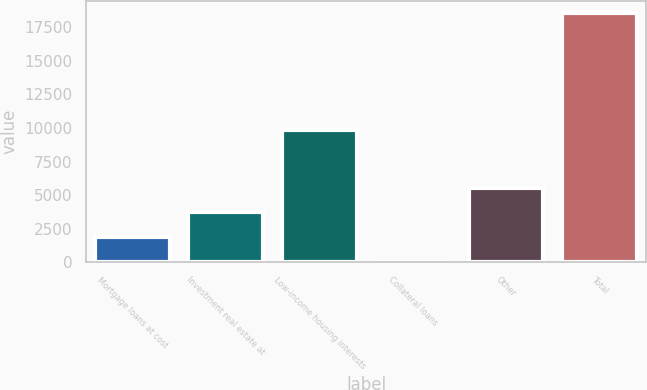<chart> <loc_0><loc_0><loc_500><loc_500><bar_chart><fcel>Mortgage loans at cost<fcel>Investment real estate at<fcel>Low-income housing interests<fcel>Collateral loans<fcel>Other<fcel>Total<nl><fcel>1856.65<fcel>3710.24<fcel>9875<fcel>3.06<fcel>5563.83<fcel>18539<nl></chart> 